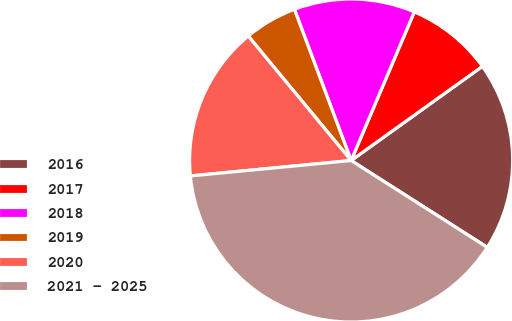<chart> <loc_0><loc_0><loc_500><loc_500><pie_chart><fcel>2016<fcel>2017<fcel>2018<fcel>2019<fcel>2020<fcel>2021 - 2025<nl><fcel>18.94%<fcel>8.7%<fcel>12.11%<fcel>5.28%<fcel>15.53%<fcel>39.44%<nl></chart> 